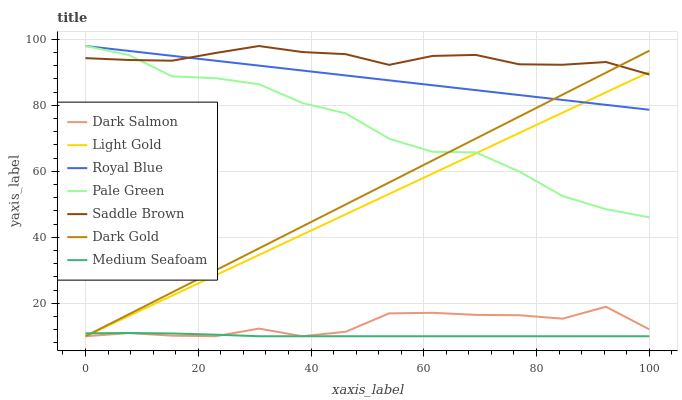Does Medium Seafoam have the minimum area under the curve?
Answer yes or no. Yes. Does Saddle Brown have the maximum area under the curve?
Answer yes or no. Yes. Does Dark Salmon have the minimum area under the curve?
Answer yes or no. No. Does Dark Salmon have the maximum area under the curve?
Answer yes or no. No. Is Dark Gold the smoothest?
Answer yes or no. Yes. Is Pale Green the roughest?
Answer yes or no. Yes. Is Dark Salmon the smoothest?
Answer yes or no. No. Is Dark Salmon the roughest?
Answer yes or no. No. Does Dark Gold have the lowest value?
Answer yes or no. Yes. Does Royal Blue have the lowest value?
Answer yes or no. No. Does Saddle Brown have the highest value?
Answer yes or no. Yes. Does Dark Salmon have the highest value?
Answer yes or no. No. Is Dark Salmon less than Saddle Brown?
Answer yes or no. Yes. Is Royal Blue greater than Dark Salmon?
Answer yes or no. Yes. Does Light Gold intersect Dark Gold?
Answer yes or no. Yes. Is Light Gold less than Dark Gold?
Answer yes or no. No. Is Light Gold greater than Dark Gold?
Answer yes or no. No. Does Dark Salmon intersect Saddle Brown?
Answer yes or no. No. 